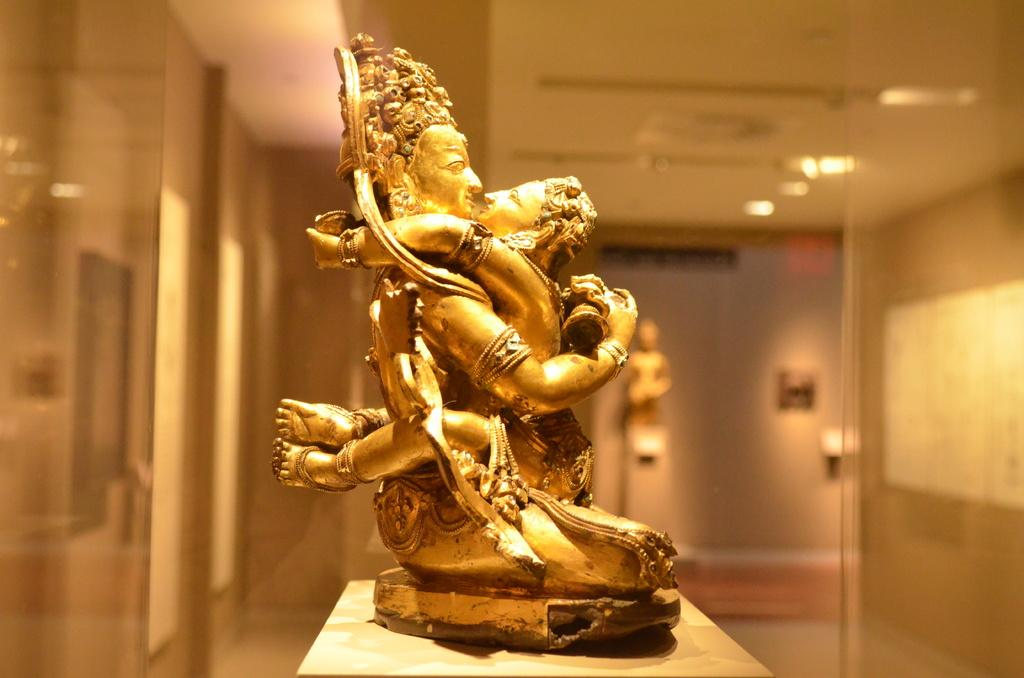What is the main subject of the image? There is a statue on a platform in the image. What can be seen in the background of the image? There are lights, walls, and a roof in the background of the image. How would you describe the quality of the background in the image? The background of the image is blurry. Can you see any sheep near the statue in the image? There are no sheep present in the image. How does the statue pull itself up onto the platform in the image? The statue does not move or pull itself up in the image; it is stationary on the platform. 